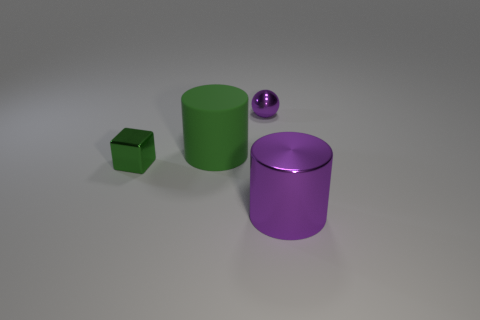Are there any cubes that have the same material as the purple cylinder?
Provide a short and direct response. Yes. Does the ball have the same material as the tiny green object?
Ensure brevity in your answer.  Yes. How many gray objects are either large matte cylinders or big metallic cylinders?
Offer a terse response. 0. Is the number of big rubber objects on the left side of the big matte cylinder greater than the number of tiny spheres?
Ensure brevity in your answer.  No. Is there a large metal cylinder that has the same color as the metallic sphere?
Your answer should be compact. Yes. The rubber object is what size?
Offer a terse response. Large. Is the color of the tiny cube the same as the large metallic cylinder?
Your response must be concise. No. How many things are either small purple spheres or cylinders on the right side of the big green rubber object?
Provide a short and direct response. 2. Are there the same number of tiny brown metallic cylinders and large cylinders?
Your response must be concise. No. There is a thing behind the large thing behind the small shiny cube; how many large purple cylinders are on the left side of it?
Your answer should be compact. 0. 